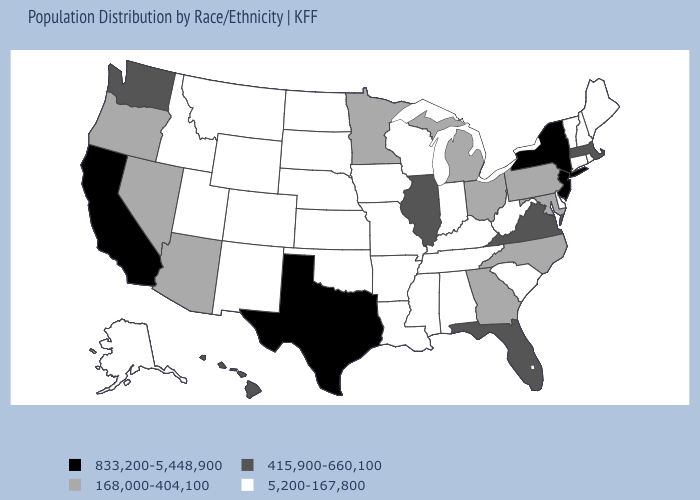Name the states that have a value in the range 415,900-660,100?
Be succinct. Florida, Hawaii, Illinois, Massachusetts, Virginia, Washington. Does Massachusetts have a lower value than California?
Short answer required. Yes. Does the first symbol in the legend represent the smallest category?
Concise answer only. No. Among the states that border Georgia , which have the lowest value?
Concise answer only. Alabama, South Carolina, Tennessee. Name the states that have a value in the range 168,000-404,100?
Give a very brief answer. Arizona, Georgia, Maryland, Michigan, Minnesota, Nevada, North Carolina, Ohio, Oregon, Pennsylvania. What is the value of South Carolina?
Write a very short answer. 5,200-167,800. Among the states that border New York , which have the highest value?
Answer briefly. New Jersey. Name the states that have a value in the range 5,200-167,800?
Answer briefly. Alabama, Alaska, Arkansas, Colorado, Connecticut, Delaware, Idaho, Indiana, Iowa, Kansas, Kentucky, Louisiana, Maine, Mississippi, Missouri, Montana, Nebraska, New Hampshire, New Mexico, North Dakota, Oklahoma, Rhode Island, South Carolina, South Dakota, Tennessee, Utah, Vermont, West Virginia, Wisconsin, Wyoming. What is the value of Iowa?
Short answer required. 5,200-167,800. Among the states that border Arkansas , does Texas have the lowest value?
Give a very brief answer. No. Which states have the lowest value in the MidWest?
Give a very brief answer. Indiana, Iowa, Kansas, Missouri, Nebraska, North Dakota, South Dakota, Wisconsin. Name the states that have a value in the range 168,000-404,100?
Concise answer only. Arizona, Georgia, Maryland, Michigan, Minnesota, Nevada, North Carolina, Ohio, Oregon, Pennsylvania. Which states have the highest value in the USA?
Concise answer only. California, New Jersey, New York, Texas. What is the value of New York?
Be succinct. 833,200-5,448,900. What is the value of Ohio?
Write a very short answer. 168,000-404,100. 